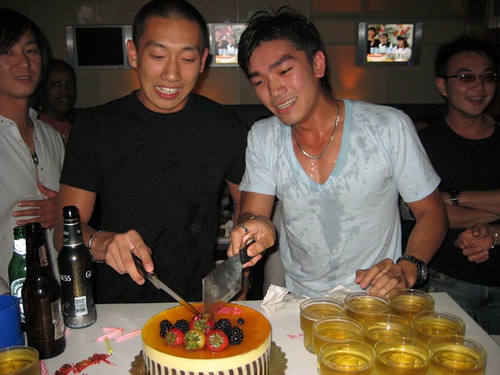Describe the objects in this image and their specific colors. I can see people in black, darkgray, brown, and maroon tones, people in black, brown, and maroon tones, people in black, maroon, and gray tones, people in black, gray, maroon, and brown tones, and dining table in black, darkgray, gray, and lightgray tones in this image. 